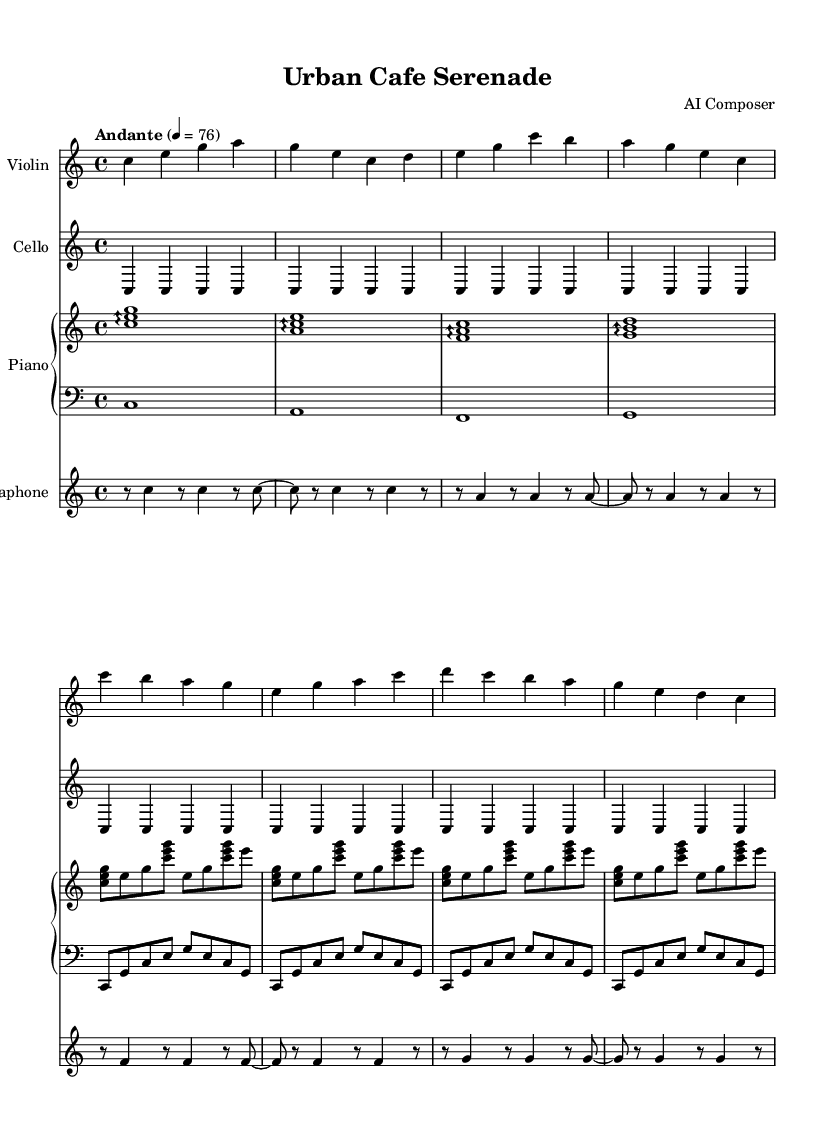What is the key signature of this music? The key signature is C major, which has no sharps or flats indicated at the beginning of the staff.
Answer: C major What is the time signature of this piece? The time signature is shown as 4/4, which means there are four beats per measure with each beat being a quarter note.
Answer: 4/4 What is the tempo marking provided? The tempo marking is indicated as "Andante" with a metronome marking of 76, which suggests a moderate walking pace.
Answer: Andante 4 = 76 How many instruments are featured in this score? Counting the staves, there are four instruments: Violin, Cello, Piano (two staves), and Vibraphone.
Answer: Four What is the rhythmic value of the first note in the violin part? In the violin part, the first note is a quarter note, indicated by the symbol for a single filled note head with a stem.
Answer: Quarter note Which instrument plays a repeating pattern in the cello part? The cello part features a repeating pattern of a single note, specifically the note C, played in a consistent manner over multiple measures.
Answer: Cello What type of musical texture is primarily presented in this composition? The composition uses a layered texture with distinct melodies and harmonies from multiple instruments, creating a rich modern sound typical of minimalist orchestral works.
Answer: Layered texture 